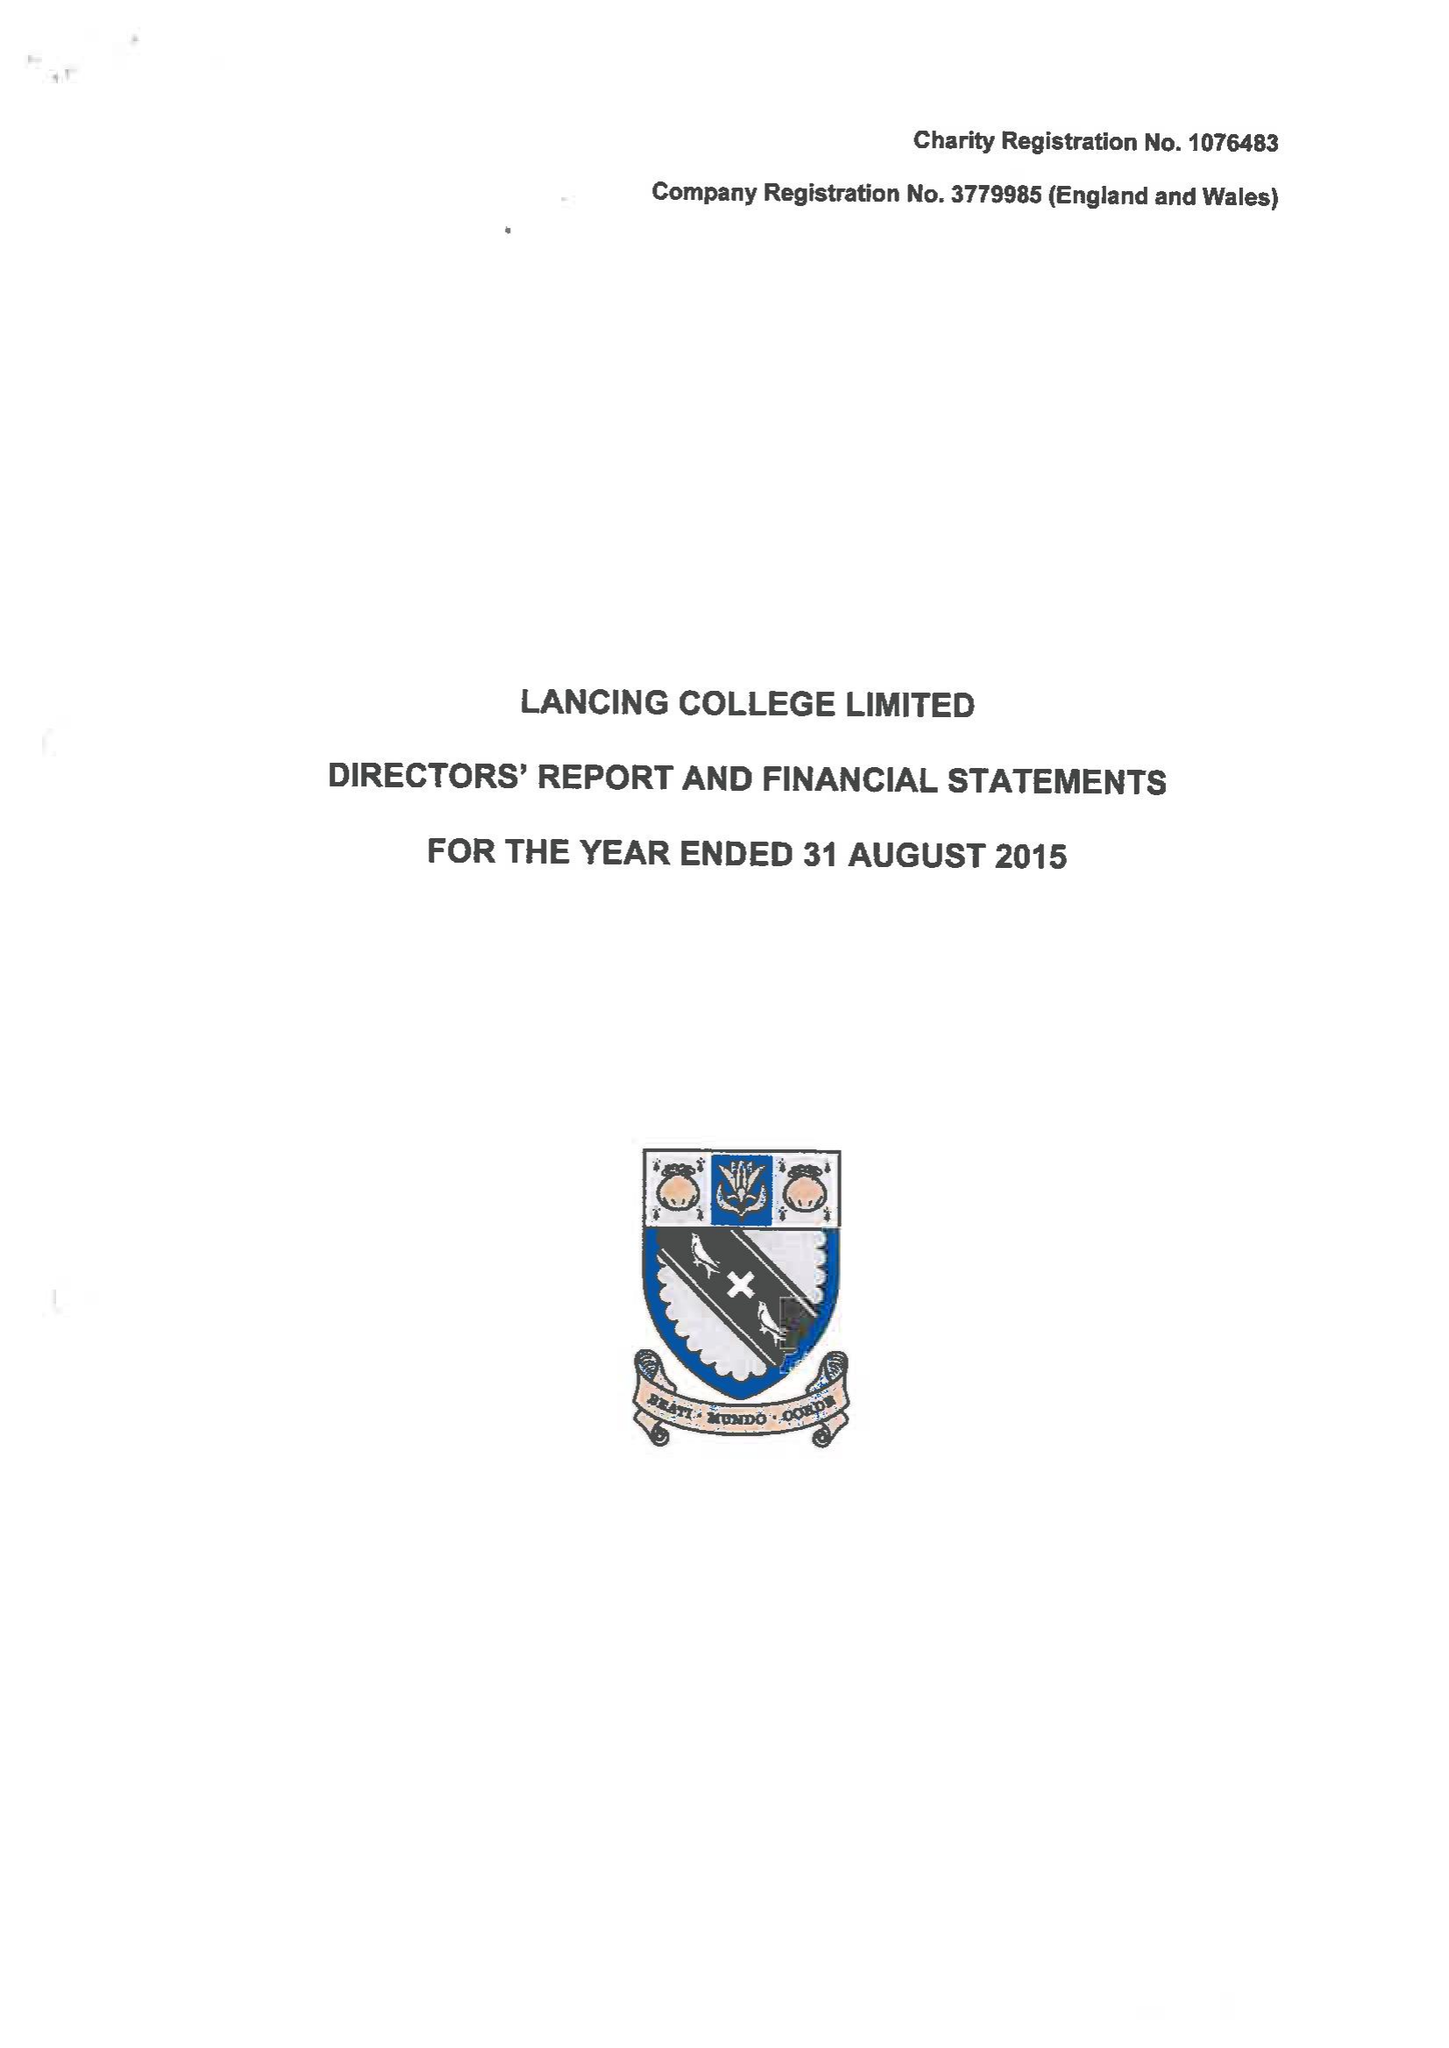What is the value for the report_date?
Answer the question using a single word or phrase. 2015-08-31 